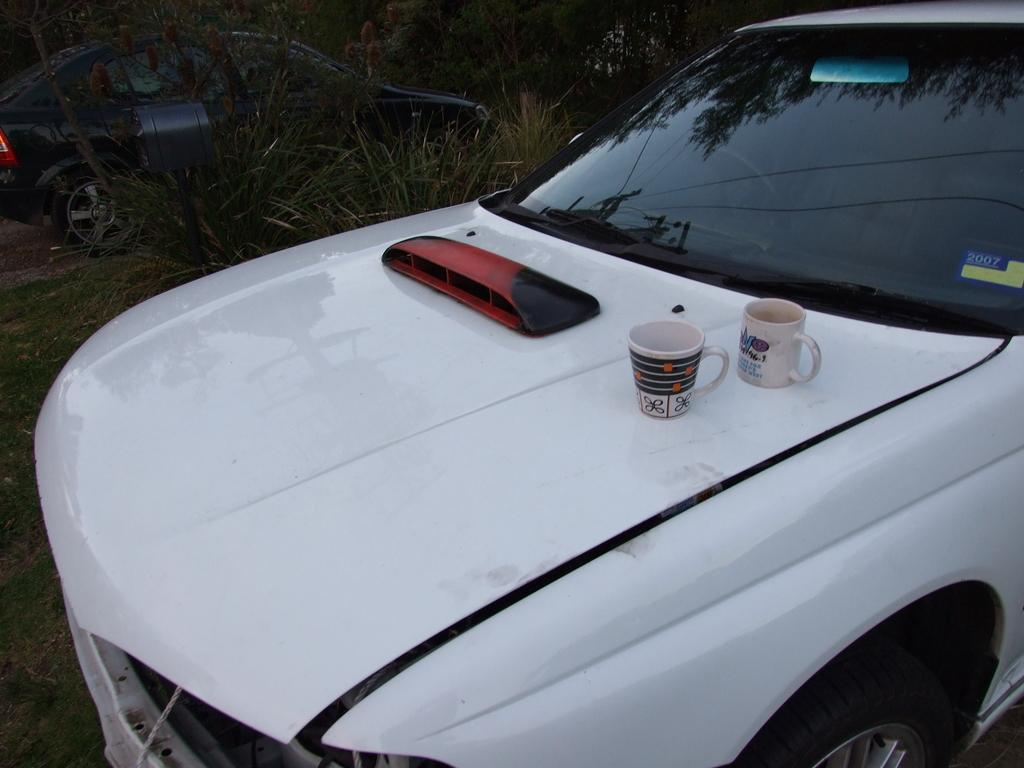What types of objects are present in the image? There are vehicles, cups, and an object on one of the vehicles in the image. What else can be seen in the image besides the vehicles and cups? There are plants and trees in the image. What grade is the beginner driver of the vehicle in the image? There is no information about a driver or their grade in the image. 